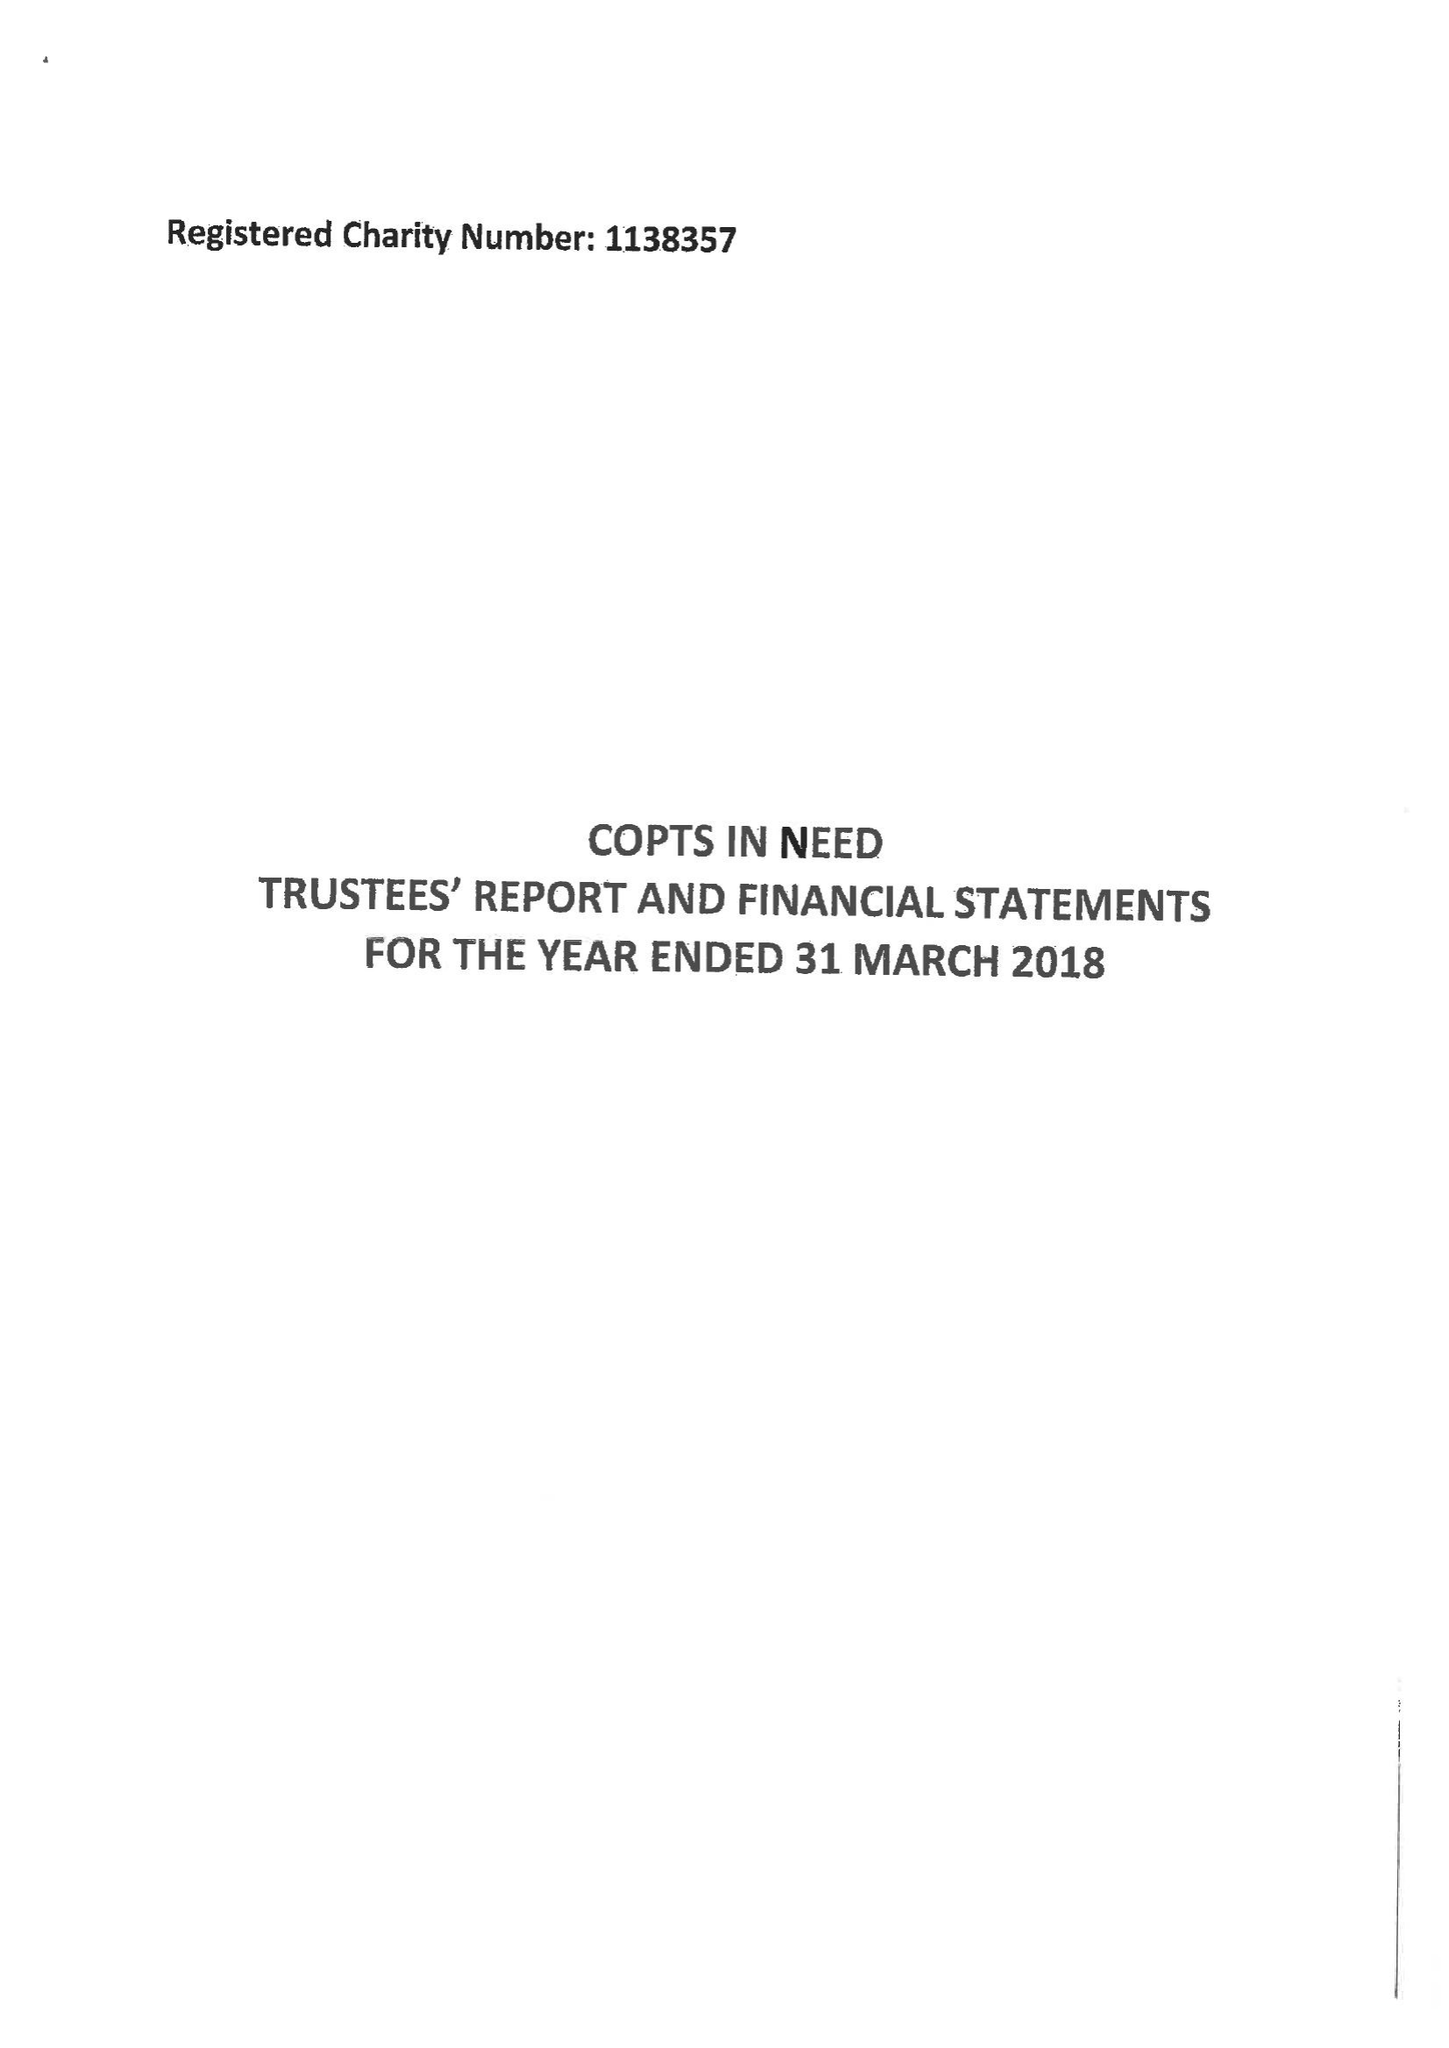What is the value for the address__postcode?
Answer the question using a single word or phrase. TS22 5RL 